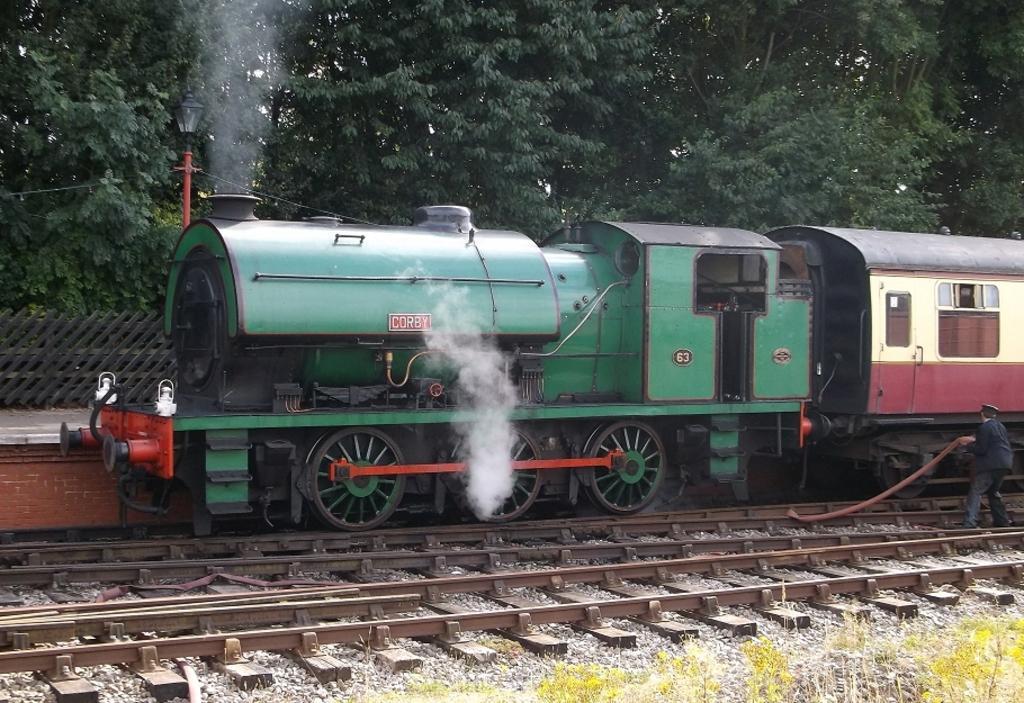In one or two sentences, can you explain what this image depicts? In the center of the image we can see train, smoke, lamp, pole, wires, railway tracks, platform are there. On the right side of the image a person is standing and holding a pipe. On the right side of the image we can see some stones, plants are there. At the top of the image trees are there. 